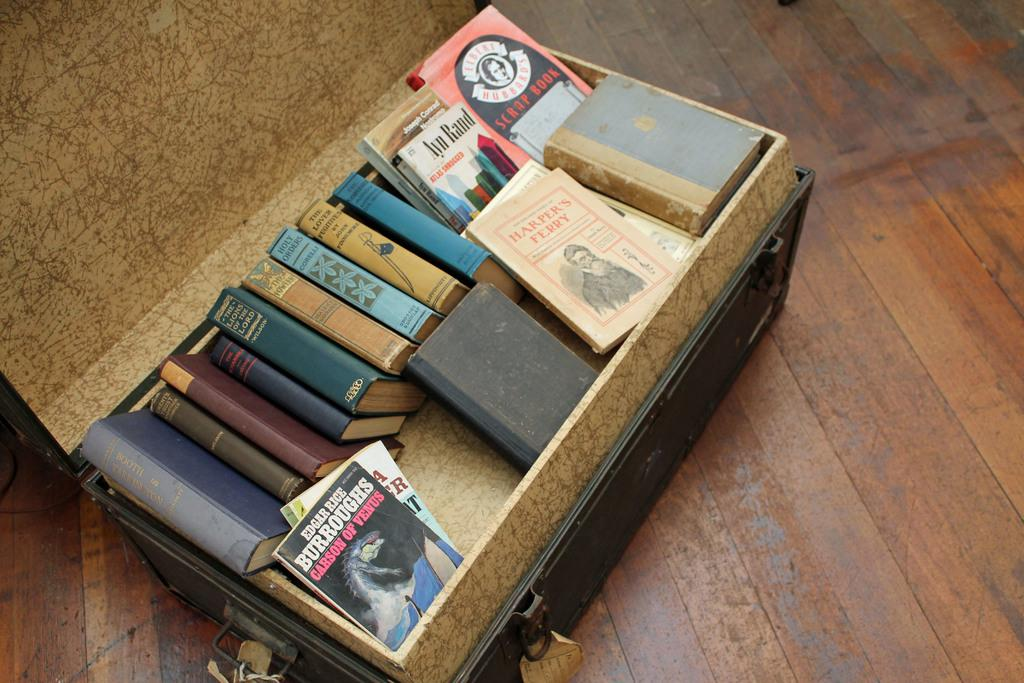<image>
Present a compact description of the photo's key features. Multiple books are in a box including one from Edgar Rice Burroughs titled Carson of Venus. 